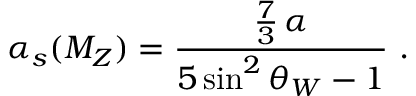Convert formula to latex. <formula><loc_0><loc_0><loc_500><loc_500>\alpha _ { s } ( M _ { Z } ) = { \frac { { \frac { 7 } { 3 } } \, \alpha } { 5 \sin ^ { 2 } \theta _ { W } - 1 } } \ .</formula> 